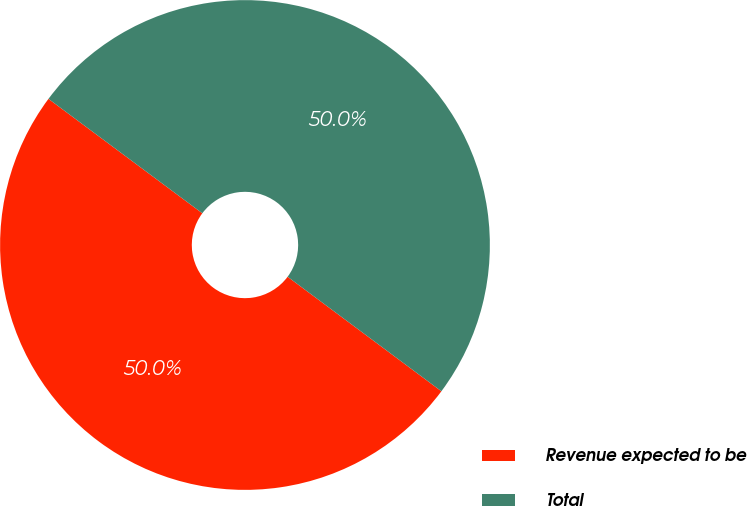<chart> <loc_0><loc_0><loc_500><loc_500><pie_chart><fcel>Revenue expected to be<fcel>Total<nl><fcel>49.99%<fcel>50.01%<nl></chart> 